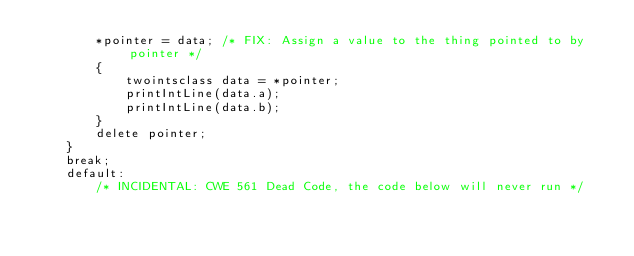<code> <loc_0><loc_0><loc_500><loc_500><_C++_>        *pointer = data; /* FIX: Assign a value to the thing pointed to by pointer */
        {
            twointsclass data = *pointer;
            printIntLine(data.a);
            printIntLine(data.b);
        }
        delete pointer;
    }
    break;
    default:
        /* INCIDENTAL: CWE 561 Dead Code, the code below will never run */</code> 